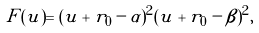<formula> <loc_0><loc_0><loc_500><loc_500>F ( u ) = ( u + r _ { 0 } - \alpha ) ^ { 2 } ( u + r _ { 0 } - \beta ) ^ { 2 } ,</formula> 